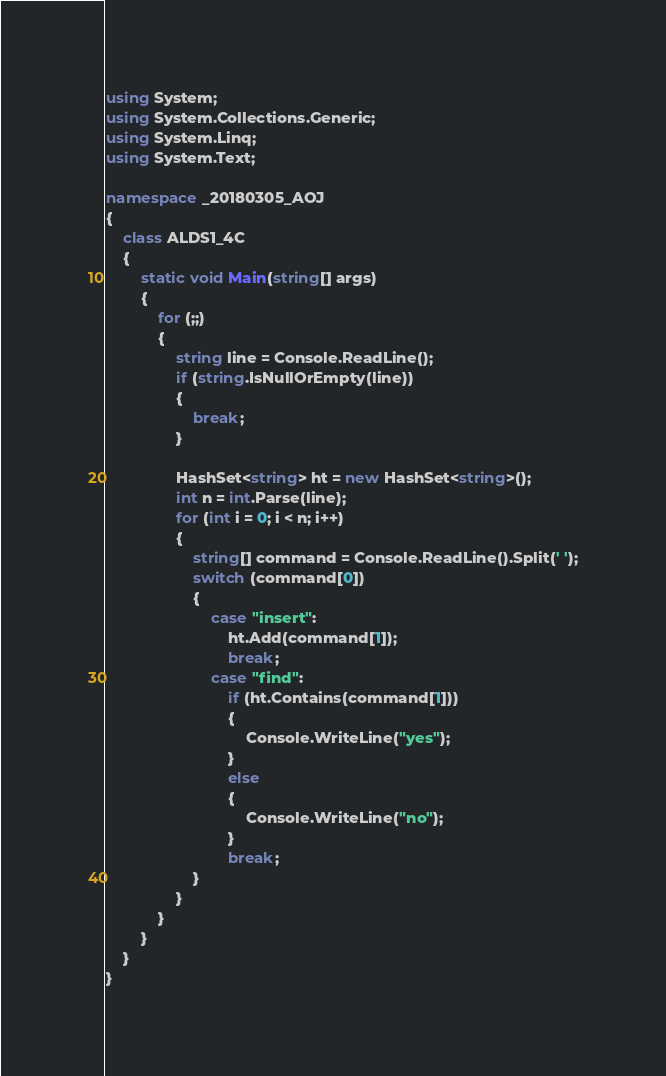<code> <loc_0><loc_0><loc_500><loc_500><_C#_>using System;
using System.Collections.Generic;
using System.Linq;
using System.Text;

namespace _20180305_AOJ
{
    class ALDS1_4C
    {
        static void Main(string[] args)
        {
            for (;;)
            {
                string line = Console.ReadLine();
                if (string.IsNullOrEmpty(line))
                {
                    break;
                }

                HashSet<string> ht = new HashSet<string>();
                int n = int.Parse(line);
                for (int i = 0; i < n; i++)
                {
                    string[] command = Console.ReadLine().Split(' ');
                    switch (command[0])
                    {
                        case "insert":
                            ht.Add(command[1]);
                            break;
                        case "find":
                            if (ht.Contains(command[1]))
                            {
                                Console.WriteLine("yes");
                            }
                            else
                            {
                                Console.WriteLine("no");
                            }
                            break;
                    }
                }
            }
        }
    }
}

</code> 